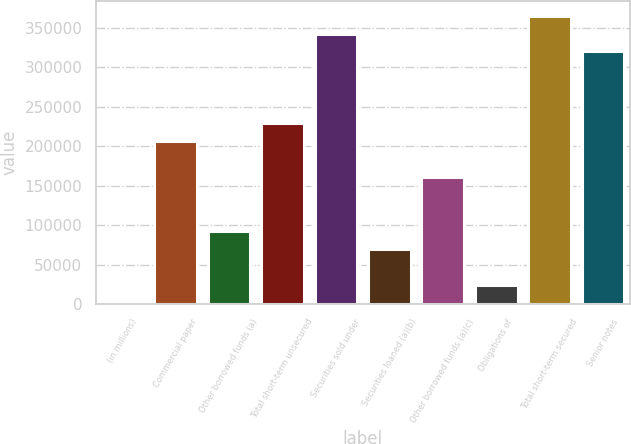Convert chart to OTSL. <chart><loc_0><loc_0><loc_500><loc_500><bar_chart><fcel>(in millions)<fcel>Commercial paper<fcel>Other borrowed funds (a)<fcel>Total short-term unsecured<fcel>Securities sold under<fcel>Securities loaned (a)(b)<fcel>Other borrowed funds (a)(c)<fcel>Obligations of<fcel>Total short-term secured<fcel>Senior notes<nl><fcel>2018<fcel>206502<fcel>92899.6<fcel>229222<fcel>342824<fcel>70179.2<fcel>161061<fcel>24738.4<fcel>365544<fcel>320104<nl></chart> 